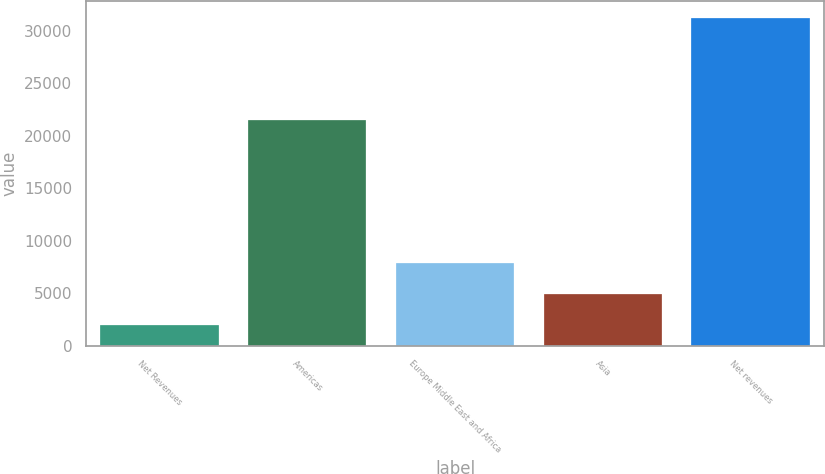<chart> <loc_0><loc_0><loc_500><loc_500><bar_chart><fcel>Net Revenues<fcel>Americas<fcel>Europe Middle East and Africa<fcel>Asia<fcel>Net revenues<nl><fcel>2010<fcel>21452<fcel>7854<fcel>4932<fcel>31230<nl></chart> 